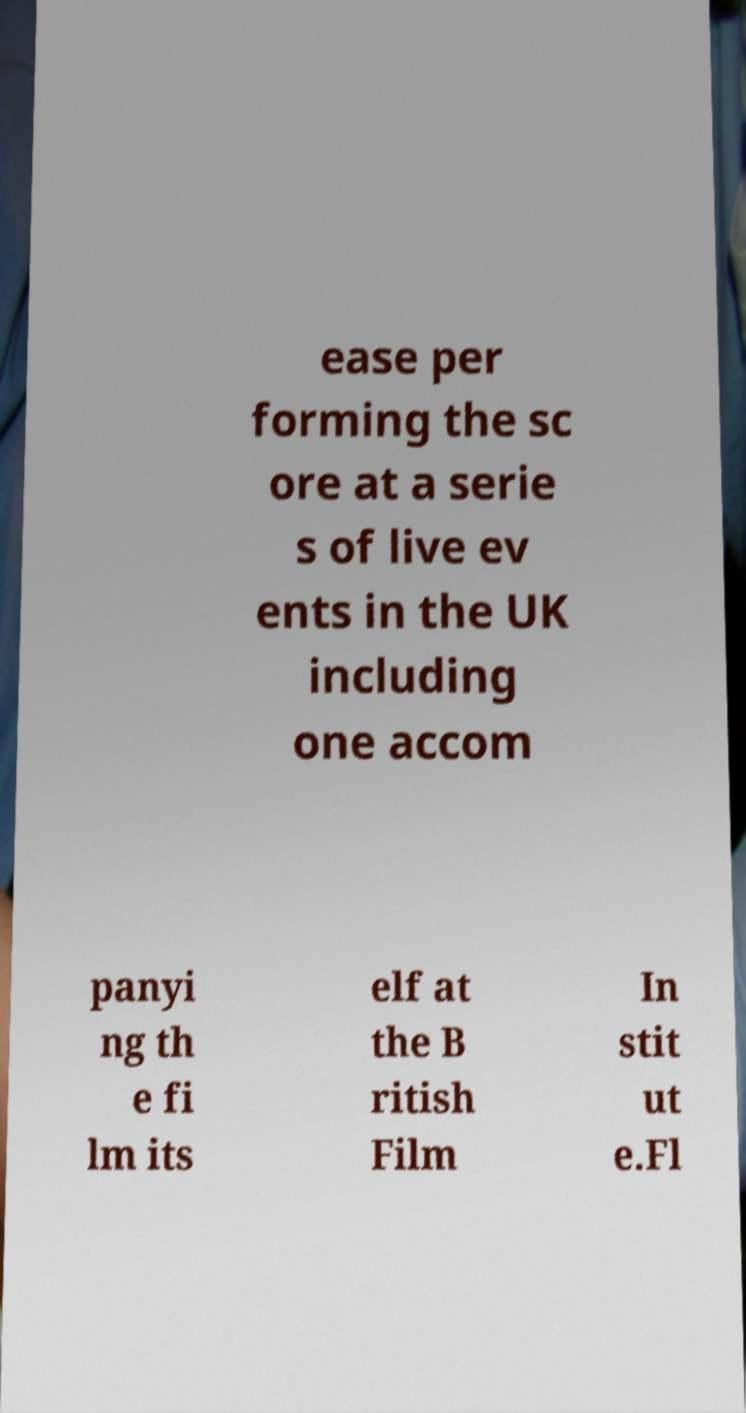There's text embedded in this image that I need extracted. Can you transcribe it verbatim? ease per forming the sc ore at a serie s of live ev ents in the UK including one accom panyi ng th e fi lm its elf at the B ritish Film In stit ut e.Fl 